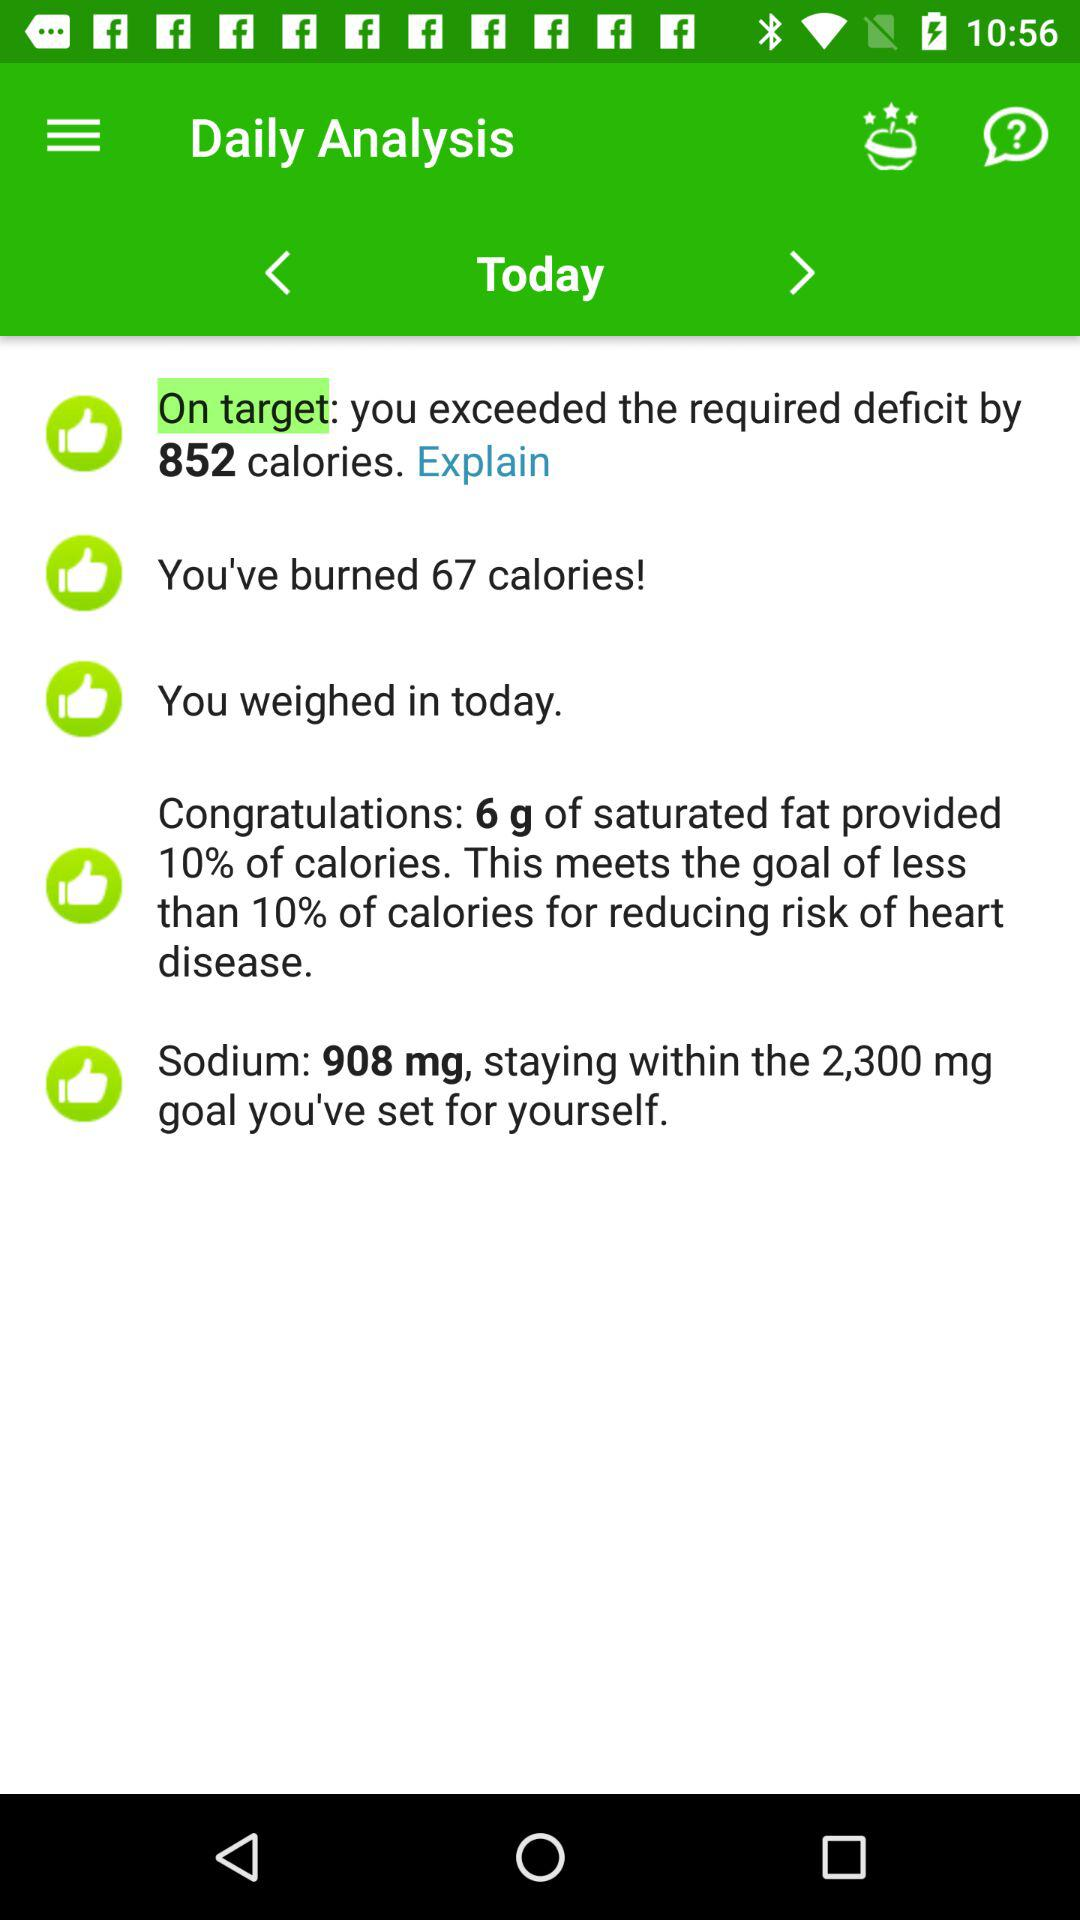How many calories are exceeded? The calories are 852. 